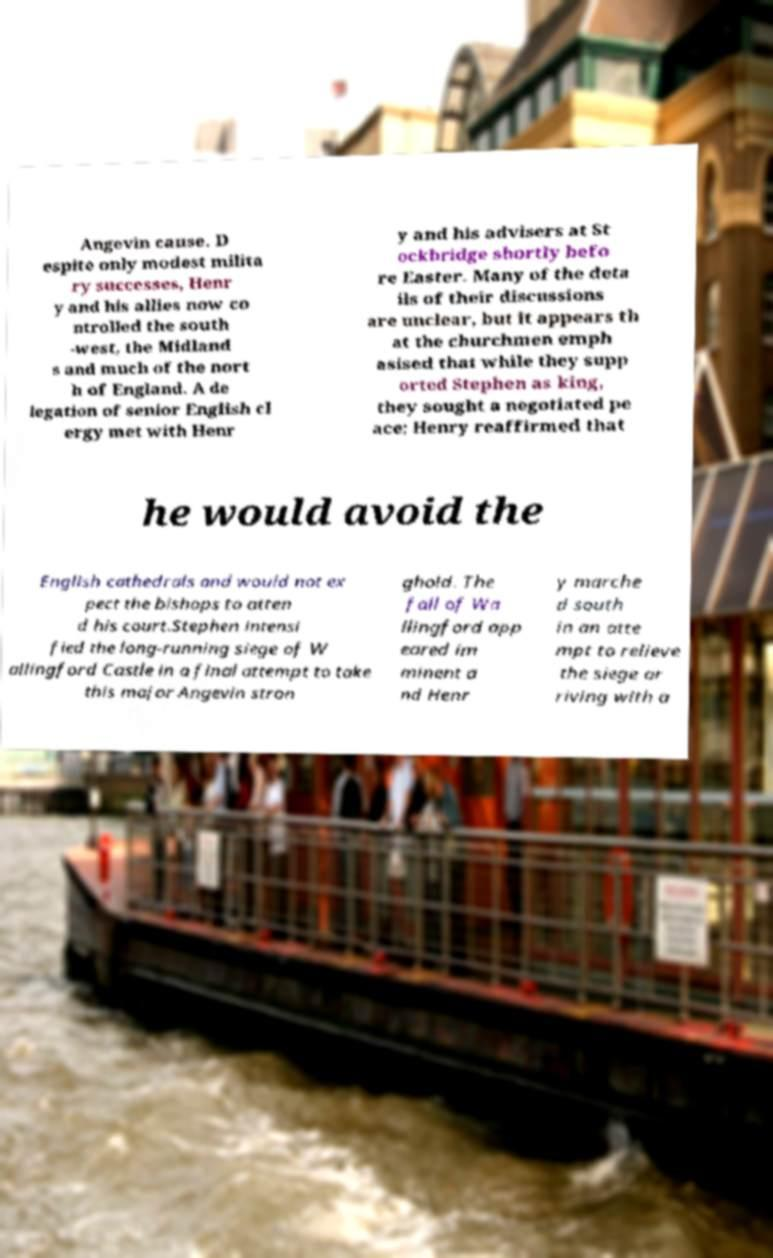I need the written content from this picture converted into text. Can you do that? Angevin cause. D espite only modest milita ry successes, Henr y and his allies now co ntrolled the south -west, the Midland s and much of the nort h of England. A de legation of senior English cl ergy met with Henr y and his advisers at St ockbridge shortly befo re Easter. Many of the deta ils of their discussions are unclear, but it appears th at the churchmen emph asised that while they supp orted Stephen as king, they sought a negotiated pe ace; Henry reaffirmed that he would avoid the English cathedrals and would not ex pect the bishops to atten d his court.Stephen intensi fied the long-running siege of W allingford Castle in a final attempt to take this major Angevin stron ghold. The fall of Wa llingford app eared im minent a nd Henr y marche d south in an atte mpt to relieve the siege ar riving with a 